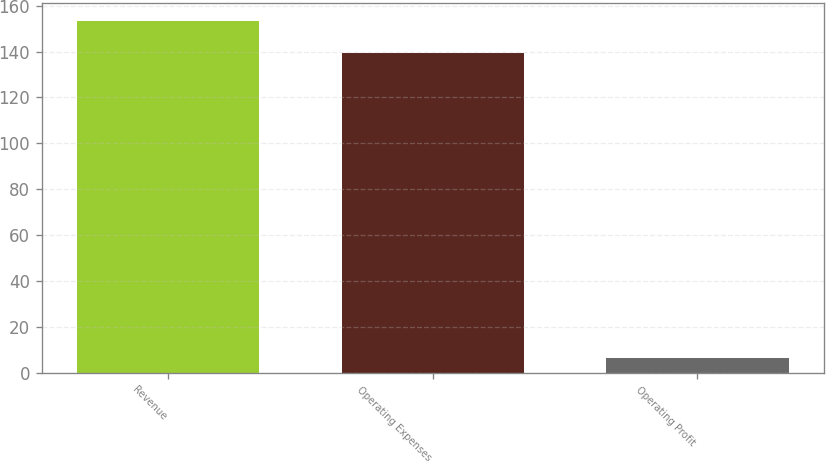<chart> <loc_0><loc_0><loc_500><loc_500><bar_chart><fcel>Revenue<fcel>Operating Expenses<fcel>Operating Profit<nl><fcel>153.45<fcel>139.5<fcel>6.6<nl></chart> 